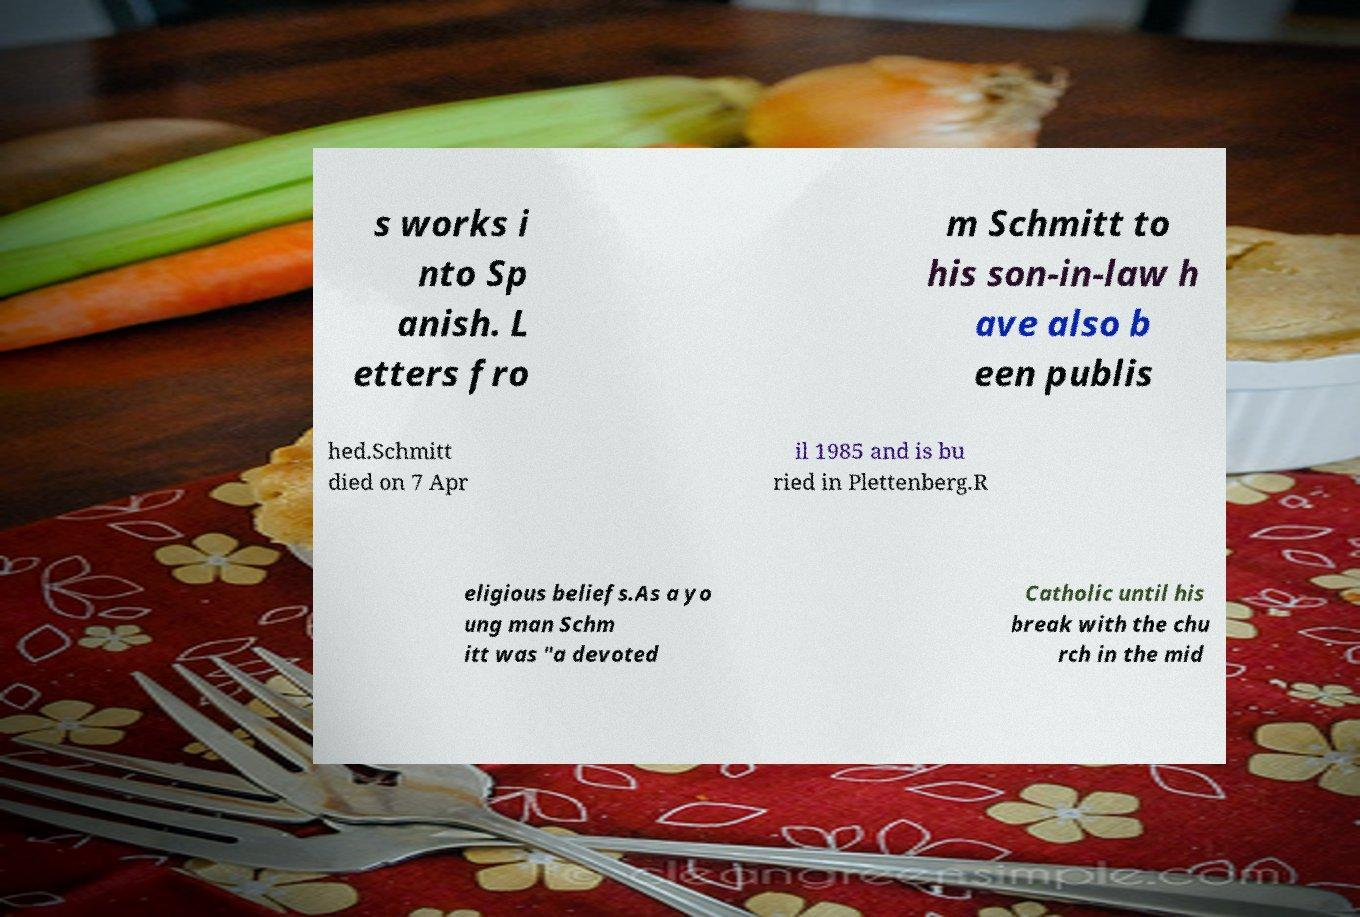Please identify and transcribe the text found in this image. s works i nto Sp anish. L etters fro m Schmitt to his son-in-law h ave also b een publis hed.Schmitt died on 7 Apr il 1985 and is bu ried in Plettenberg.R eligious beliefs.As a yo ung man Schm itt was "a devoted Catholic until his break with the chu rch in the mid 